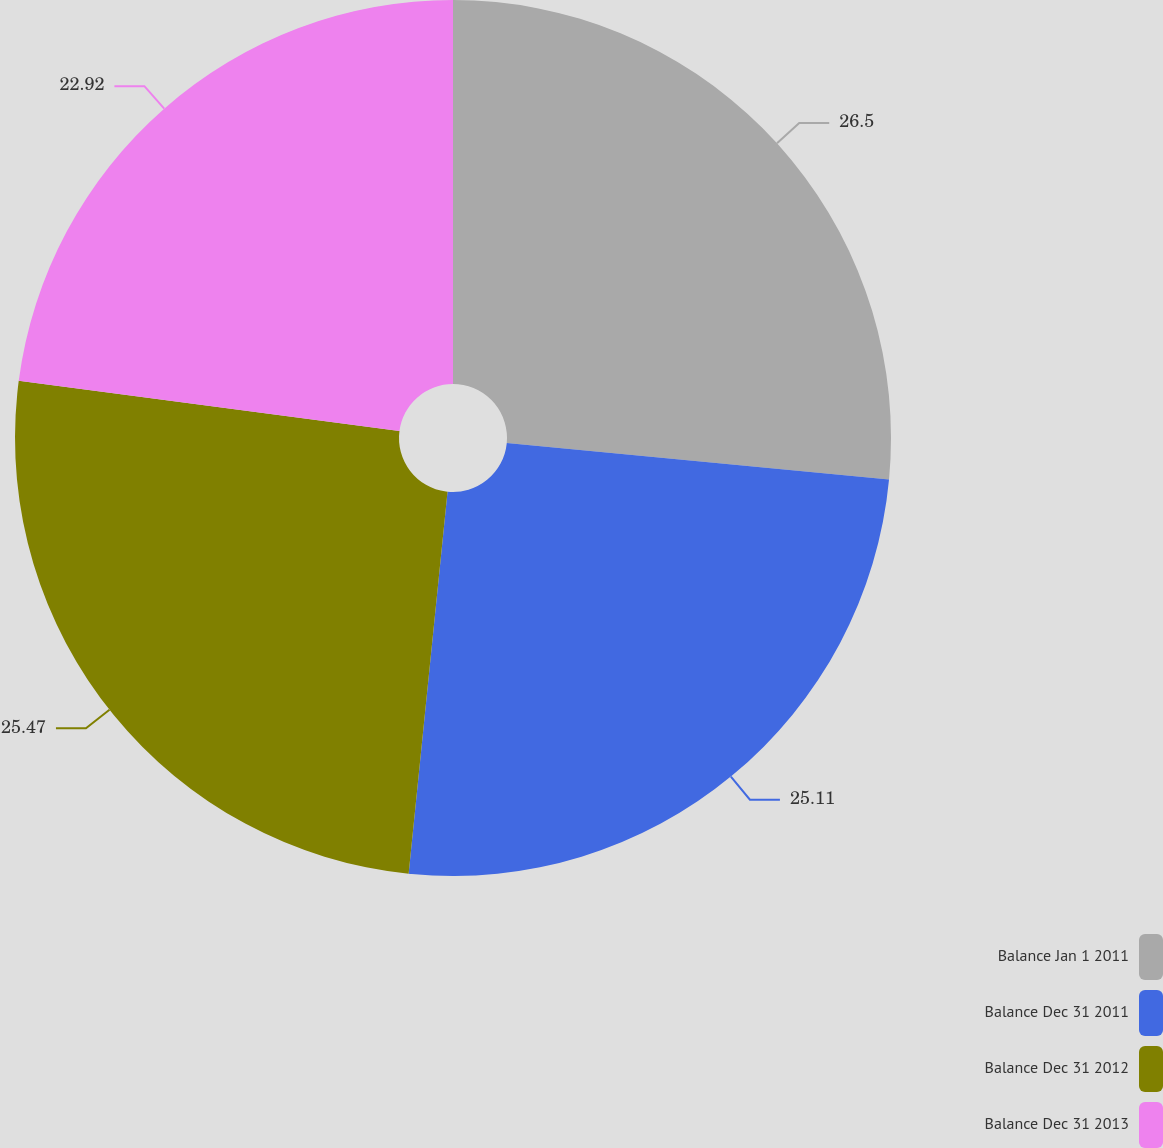<chart> <loc_0><loc_0><loc_500><loc_500><pie_chart><fcel>Balance Jan 1 2011<fcel>Balance Dec 31 2011<fcel>Balance Dec 31 2012<fcel>Balance Dec 31 2013<nl><fcel>26.51%<fcel>25.11%<fcel>25.47%<fcel>22.92%<nl></chart> 